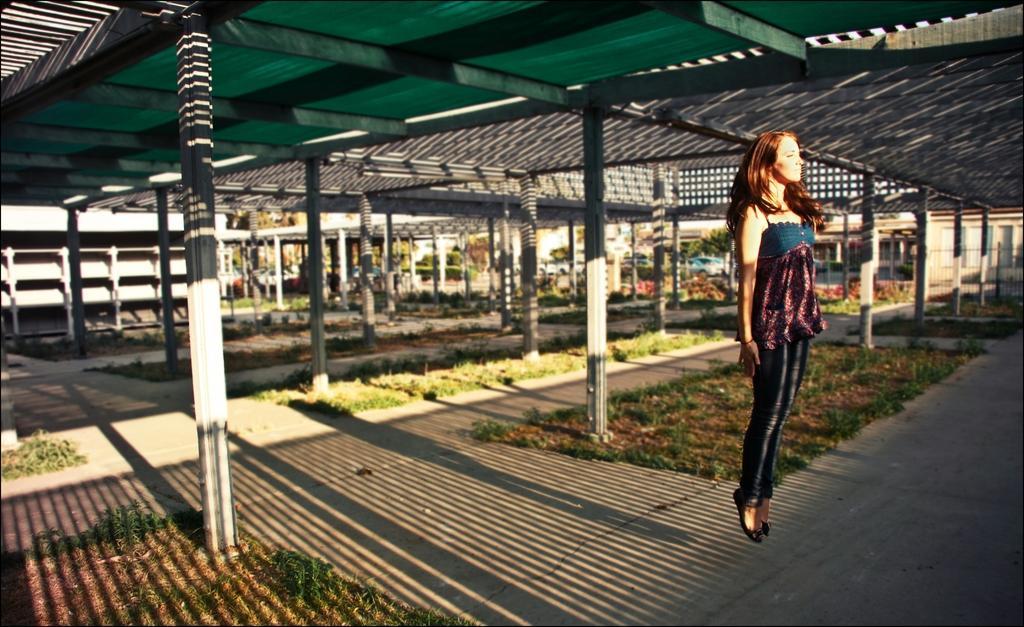Describe this image in one or two sentences. In front of the image there is a person jumping in the air. There is a metal shed supported by metal rods. There are pillars, plants. At the bottom of the image there is grass on the surface. In the background of the image there are cars, buildings and trees. 